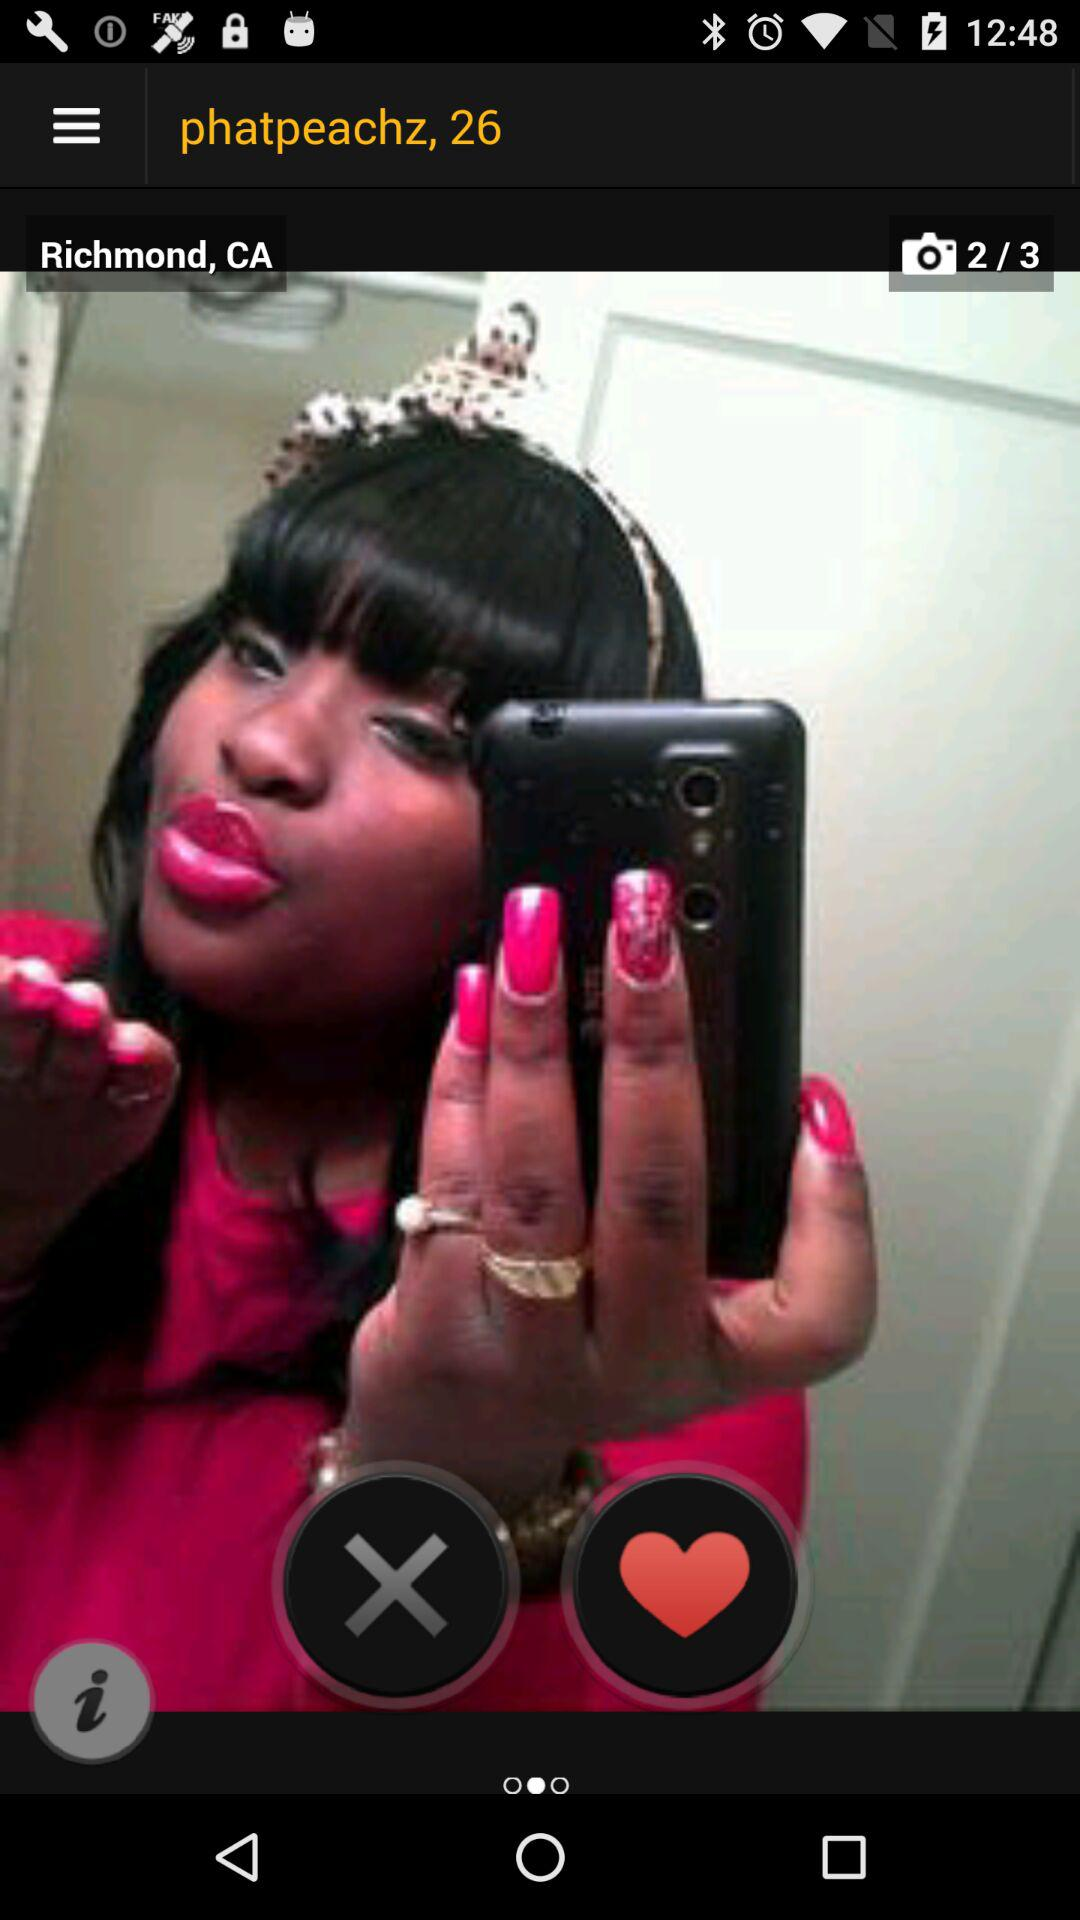What is the username? The username is "phatpeachz". 